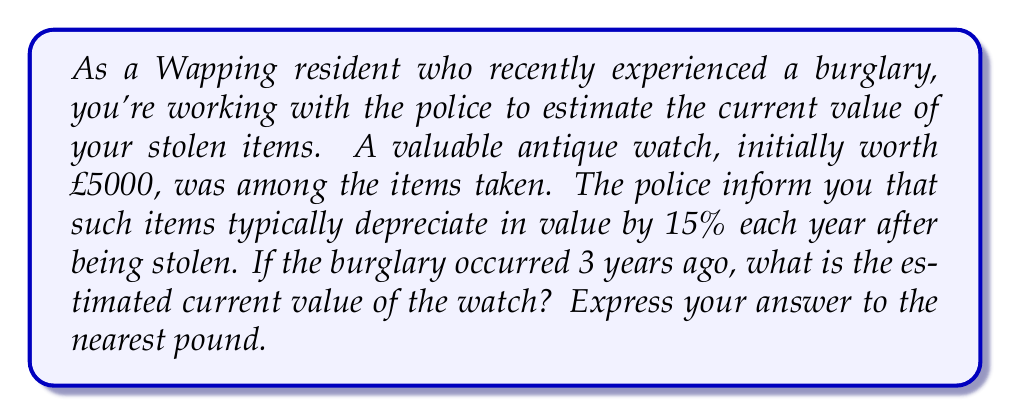What is the answer to this math problem? To solve this problem, we'll use an exponential function to model the depreciation of the watch's value over time.

1) Let's define our variables:
   $P_0$ = initial value of the watch = £5000
   $r$ = annual depreciation rate = 15% = 0.15
   $t$ = time elapsed since the burglary = 3 years

2) The exponential function for depreciation is:
   $P(t) = P_0(1-r)^t$

   Where $P(t)$ is the value after $t$ years.

3) Substituting our values:
   $P(3) = 5000(1-0.15)^3$

4) Simplify inside the parentheses:
   $P(3) = 5000(0.85)^3$

5) Calculate the exponent:
   $0.85^3 = 0.614125$

6) Multiply:
   $P(3) = 5000 * 0.614125 = 3070.625$

7) Rounding to the nearest pound:
   $P(3) \approx £3071$
Answer: £3071 